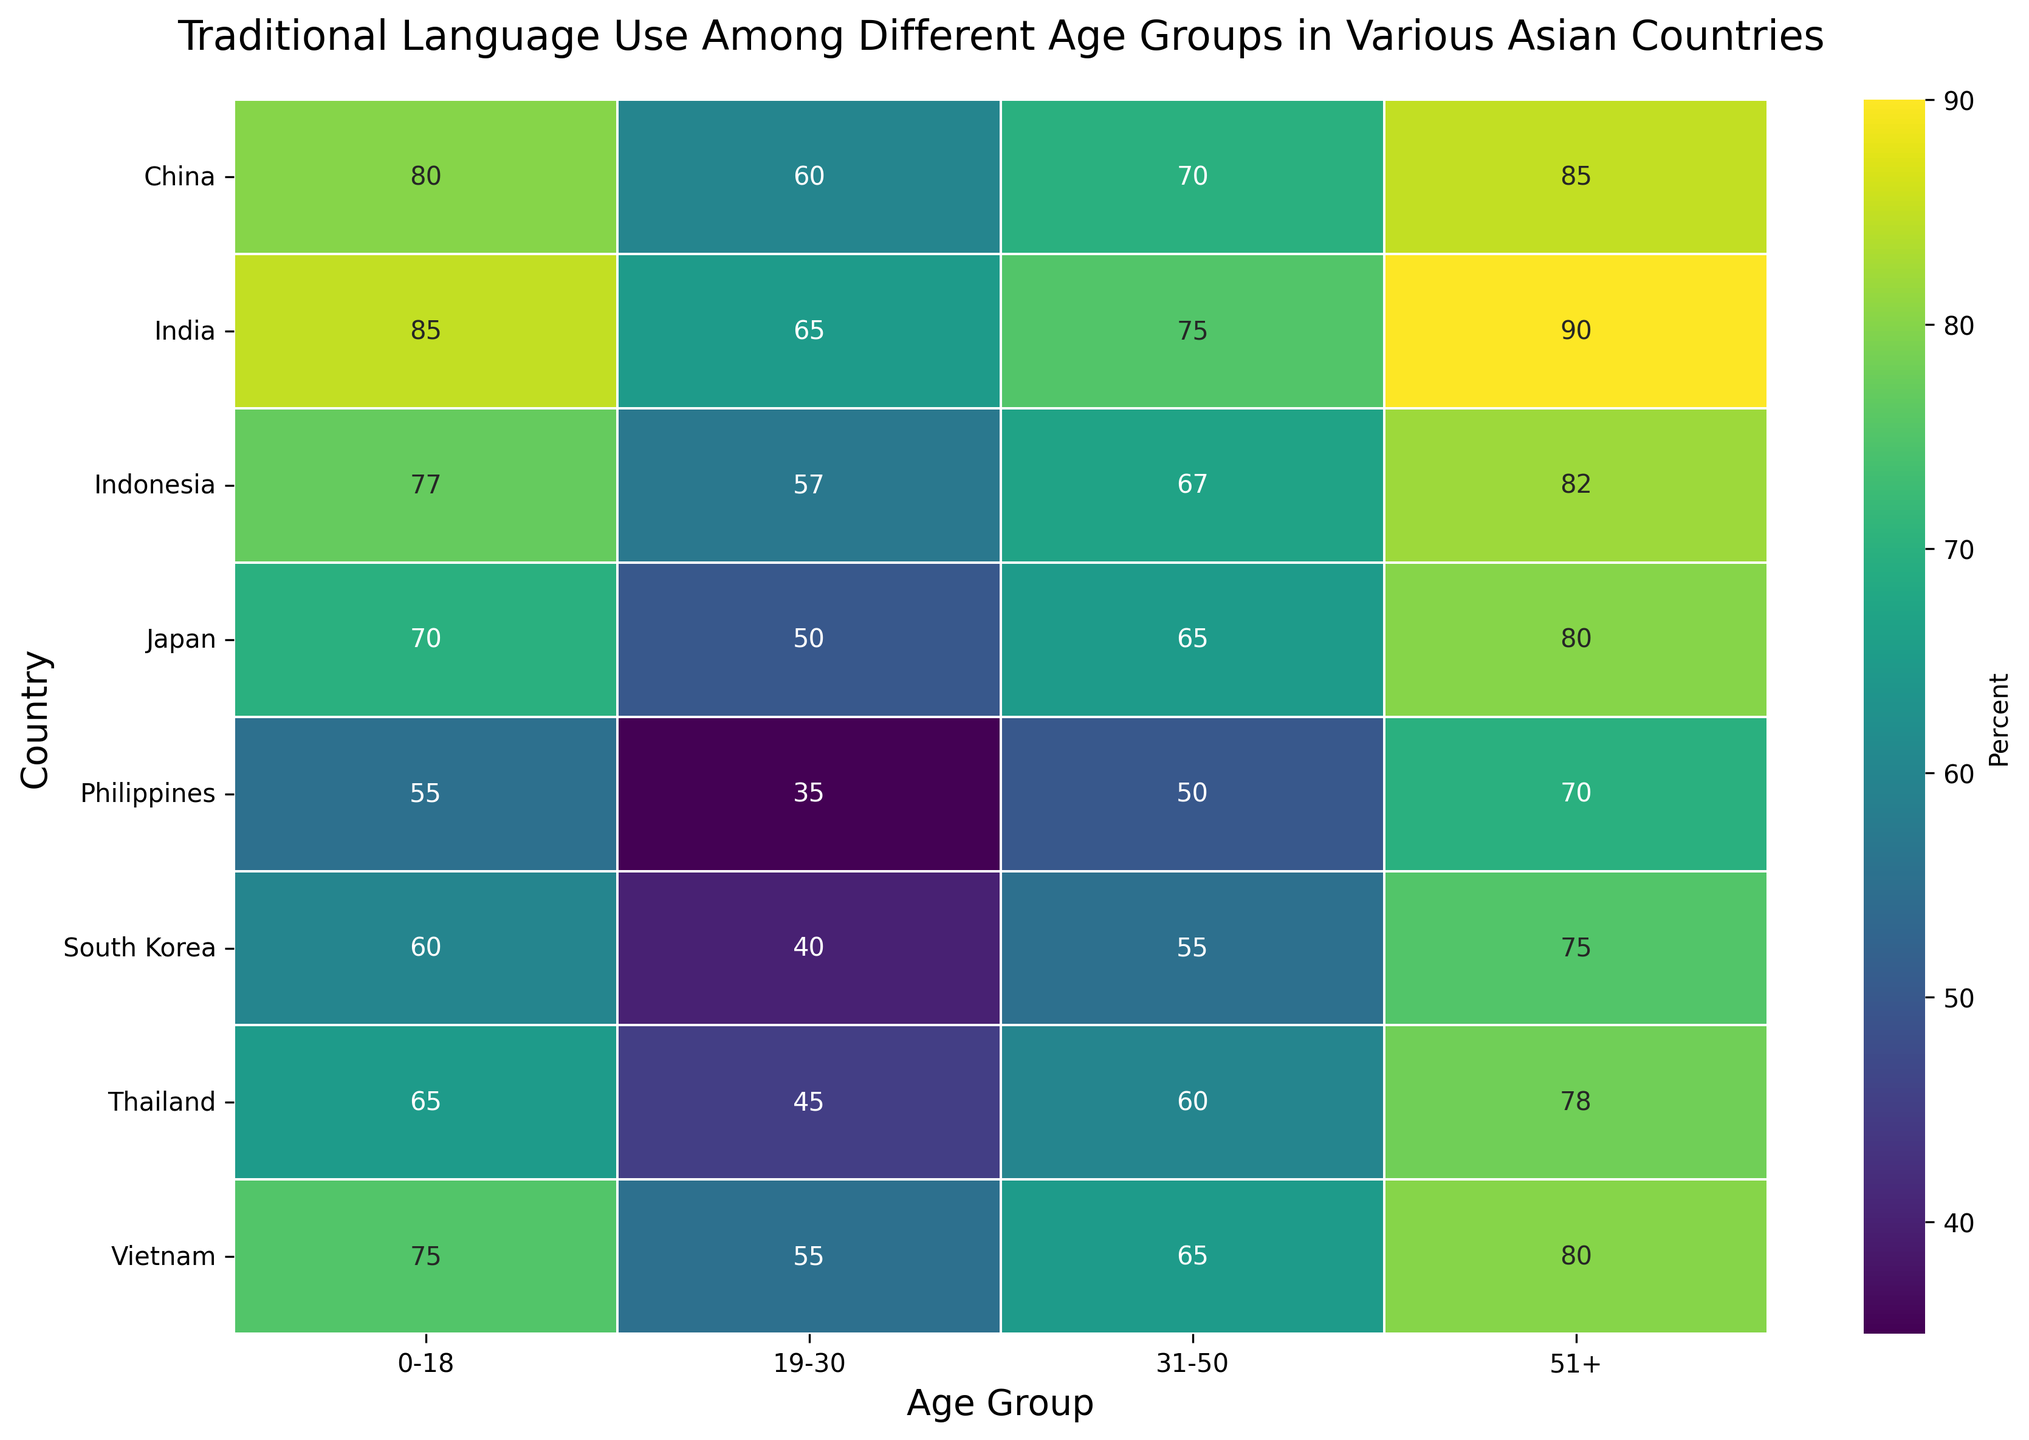What's the traditional language use percentage among the 0-18 age group in Japan? The heatmap shows various percentages of traditional language use. Look at the cell corresponding to "Japan" in the row and "0-18" in the column to find the percentage.
Answer: 70 Which age group in India has the highest traditional language use percentage? Examine the cells in the "India" row and identify the highest value among the four age groups.
Answer: 51+ Compare the traditional language use between the 19-30 age group in China and South Korea. Which country has a higher percentage? Identify the cells for the 19-30 age group in the rows for China and South Korea. Compare the two percentages.
Answer: China In which country does the 51+ age group have the highest traditional language use percentage? Look at the percentages in the column for the 51+ age group and find the highest value. Check which country this value corresponds to.
Answer: India What is the difference in traditional language use between the 0-18 and 31-50 age groups in Indonesia? Locate the cells in the "Indonesia" row for the 0-18 and 31-50 age groups. Subtract the percentage for the 31-50 age group from that of the 0-18 age group.
Answer: 10 Which two neighboring age groups in Japan have the smallest difference in traditional language use percentage? In the "Japan" row, calculate the differences between each pair of neighboring age groups (0-18 to 19-30, 19-30 to 31-50, 31-50 to 51+). Identify the smallest difference.
Answer: 0-18 to 19-30 Is there any country where the traditional language use percentage for the 19-30 age group is equal to 50? Scan the column for the 19-30 age group and identify if any values equal 50. Also, check the corresponding country.
Answer: Japan What's the average traditional language use percentage among the 31-50 age groups across all countries? Sum up the values in the column for the 31-50 age group across all rows and divide by the number of countries. (65+55+70+75+65+67+60+50) / 8 = 63.375
Answer: 63.375 Contrast the color intensity of the cell representing Thailand's 51+ age group with that of the Philippines' 51+ age group. Which one appears darker? Compare these two cells visually based on color intensity, where darker typically means a higher percentage on the heatmap.
Answer: Thailand In Vietnam, how much does traditional language use increase from the 19-30 age group to the 51+ age group? Locate the cells for Vietnam in the rows for 19-30 and 51+ age groups. Subtract the percentage for the 19-30 age group from that of the 51+ age group.
Answer: 25 